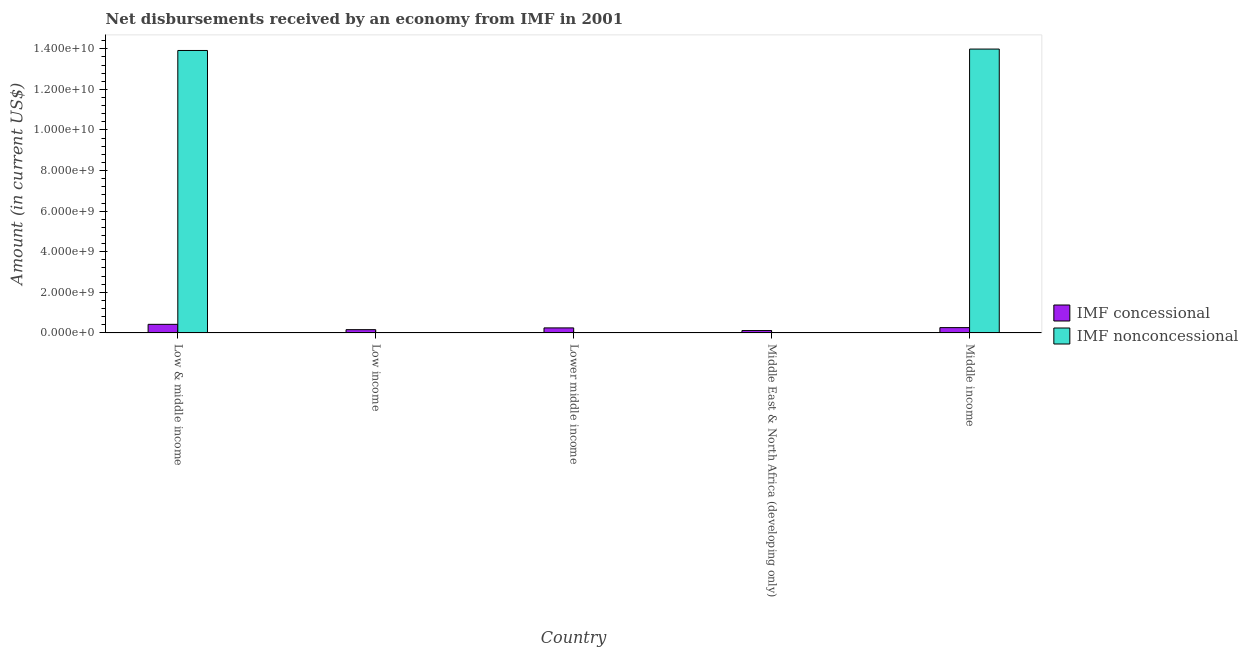How many different coloured bars are there?
Your response must be concise. 2. Are the number of bars per tick equal to the number of legend labels?
Your response must be concise. No. Are the number of bars on each tick of the X-axis equal?
Offer a very short reply. No. How many bars are there on the 1st tick from the right?
Provide a succinct answer. 2. What is the label of the 4th group of bars from the left?
Make the answer very short. Middle East & North Africa (developing only). What is the net non concessional disbursements from imf in Low income?
Keep it short and to the point. 0. Across all countries, what is the maximum net non concessional disbursements from imf?
Ensure brevity in your answer.  1.40e+1. Across all countries, what is the minimum net non concessional disbursements from imf?
Your answer should be compact. 0. What is the total net concessional disbursements from imf in the graph?
Provide a short and direct response. 1.21e+09. What is the difference between the net concessional disbursements from imf in Low & middle income and that in Lower middle income?
Your answer should be compact. 1.76e+08. What is the difference between the net non concessional disbursements from imf in Middle East & North Africa (developing only) and the net concessional disbursements from imf in Low & middle income?
Your response must be concise. -4.24e+08. What is the average net non concessional disbursements from imf per country?
Offer a very short reply. 5.58e+09. What is the difference between the net concessional disbursements from imf and net non concessional disbursements from imf in Low & middle income?
Keep it short and to the point. -1.35e+1. What is the ratio of the net non concessional disbursements from imf in Low & middle income to that in Middle income?
Ensure brevity in your answer.  1. Is the net non concessional disbursements from imf in Low & middle income less than that in Middle income?
Offer a terse response. Yes. What is the difference between the highest and the second highest net concessional disbursements from imf?
Your response must be concise. 1.62e+08. What is the difference between the highest and the lowest net concessional disbursements from imf?
Make the answer very short. 3.07e+08. Is the sum of the net concessional disbursements from imf in Lower middle income and Middle East & North Africa (developing only) greater than the maximum net non concessional disbursements from imf across all countries?
Your response must be concise. No. How many bars are there?
Provide a succinct answer. 7. What is the difference between two consecutive major ticks on the Y-axis?
Ensure brevity in your answer.  2.00e+09. Does the graph contain any zero values?
Offer a terse response. Yes. What is the title of the graph?
Offer a very short reply. Net disbursements received by an economy from IMF in 2001. Does "Resident workers" appear as one of the legend labels in the graph?
Give a very brief answer. No. What is the label or title of the X-axis?
Ensure brevity in your answer.  Country. What is the label or title of the Y-axis?
Provide a succinct answer. Amount (in current US$). What is the Amount (in current US$) of IMF concessional in Low & middle income?
Your answer should be compact. 4.24e+08. What is the Amount (in current US$) in IMF nonconcessional in Low & middle income?
Offer a terse response. 1.39e+1. What is the Amount (in current US$) of IMF concessional in Low income?
Your answer should be compact. 1.62e+08. What is the Amount (in current US$) in IMF concessional in Lower middle income?
Make the answer very short. 2.48e+08. What is the Amount (in current US$) of IMF nonconcessional in Lower middle income?
Offer a very short reply. 0. What is the Amount (in current US$) of IMF concessional in Middle East & North Africa (developing only)?
Your answer should be compact. 1.18e+08. What is the Amount (in current US$) in IMF nonconcessional in Middle East & North Africa (developing only)?
Your answer should be very brief. 0. What is the Amount (in current US$) of IMF concessional in Middle income?
Your response must be concise. 2.63e+08. What is the Amount (in current US$) in IMF nonconcessional in Middle income?
Offer a terse response. 1.40e+1. Across all countries, what is the maximum Amount (in current US$) of IMF concessional?
Ensure brevity in your answer.  4.24e+08. Across all countries, what is the maximum Amount (in current US$) of IMF nonconcessional?
Give a very brief answer. 1.40e+1. Across all countries, what is the minimum Amount (in current US$) in IMF concessional?
Offer a terse response. 1.18e+08. Across all countries, what is the minimum Amount (in current US$) in IMF nonconcessional?
Ensure brevity in your answer.  0. What is the total Amount (in current US$) in IMF concessional in the graph?
Provide a succinct answer. 1.21e+09. What is the total Amount (in current US$) in IMF nonconcessional in the graph?
Keep it short and to the point. 2.79e+1. What is the difference between the Amount (in current US$) of IMF concessional in Low & middle income and that in Low income?
Ensure brevity in your answer.  2.63e+08. What is the difference between the Amount (in current US$) of IMF concessional in Low & middle income and that in Lower middle income?
Provide a succinct answer. 1.76e+08. What is the difference between the Amount (in current US$) of IMF concessional in Low & middle income and that in Middle East & North Africa (developing only)?
Ensure brevity in your answer.  3.07e+08. What is the difference between the Amount (in current US$) of IMF concessional in Low & middle income and that in Middle income?
Give a very brief answer. 1.62e+08. What is the difference between the Amount (in current US$) in IMF nonconcessional in Low & middle income and that in Middle income?
Ensure brevity in your answer.  -6.98e+07. What is the difference between the Amount (in current US$) in IMF concessional in Low income and that in Lower middle income?
Offer a very short reply. -8.66e+07. What is the difference between the Amount (in current US$) of IMF concessional in Low income and that in Middle East & North Africa (developing only)?
Provide a succinct answer. 4.41e+07. What is the difference between the Amount (in current US$) in IMF concessional in Low income and that in Middle income?
Your answer should be very brief. -1.01e+08. What is the difference between the Amount (in current US$) in IMF concessional in Lower middle income and that in Middle East & North Africa (developing only)?
Give a very brief answer. 1.31e+08. What is the difference between the Amount (in current US$) of IMF concessional in Lower middle income and that in Middle income?
Your response must be concise. -1.43e+07. What is the difference between the Amount (in current US$) in IMF concessional in Middle East & North Africa (developing only) and that in Middle income?
Ensure brevity in your answer.  -1.45e+08. What is the difference between the Amount (in current US$) in IMF concessional in Low & middle income and the Amount (in current US$) in IMF nonconcessional in Middle income?
Provide a succinct answer. -1.36e+1. What is the difference between the Amount (in current US$) of IMF concessional in Low income and the Amount (in current US$) of IMF nonconcessional in Middle income?
Provide a short and direct response. -1.38e+1. What is the difference between the Amount (in current US$) of IMF concessional in Lower middle income and the Amount (in current US$) of IMF nonconcessional in Middle income?
Your answer should be very brief. -1.37e+1. What is the difference between the Amount (in current US$) in IMF concessional in Middle East & North Africa (developing only) and the Amount (in current US$) in IMF nonconcessional in Middle income?
Give a very brief answer. -1.39e+1. What is the average Amount (in current US$) in IMF concessional per country?
Make the answer very short. 2.43e+08. What is the average Amount (in current US$) in IMF nonconcessional per country?
Offer a very short reply. 5.58e+09. What is the difference between the Amount (in current US$) of IMF concessional and Amount (in current US$) of IMF nonconcessional in Low & middle income?
Keep it short and to the point. -1.35e+1. What is the difference between the Amount (in current US$) in IMF concessional and Amount (in current US$) in IMF nonconcessional in Middle income?
Your answer should be compact. -1.37e+1. What is the ratio of the Amount (in current US$) of IMF concessional in Low & middle income to that in Low income?
Your answer should be very brief. 2.62. What is the ratio of the Amount (in current US$) of IMF concessional in Low & middle income to that in Lower middle income?
Your response must be concise. 1.71. What is the ratio of the Amount (in current US$) of IMF concessional in Low & middle income to that in Middle East & North Africa (developing only)?
Give a very brief answer. 3.61. What is the ratio of the Amount (in current US$) of IMF concessional in Low & middle income to that in Middle income?
Offer a terse response. 1.62. What is the ratio of the Amount (in current US$) of IMF concessional in Low income to that in Lower middle income?
Your response must be concise. 0.65. What is the ratio of the Amount (in current US$) of IMF concessional in Low income to that in Middle East & North Africa (developing only)?
Your answer should be very brief. 1.37. What is the ratio of the Amount (in current US$) of IMF concessional in Low income to that in Middle income?
Offer a very short reply. 0.62. What is the ratio of the Amount (in current US$) of IMF concessional in Lower middle income to that in Middle East & North Africa (developing only)?
Ensure brevity in your answer.  2.11. What is the ratio of the Amount (in current US$) of IMF concessional in Lower middle income to that in Middle income?
Ensure brevity in your answer.  0.95. What is the ratio of the Amount (in current US$) of IMF concessional in Middle East & North Africa (developing only) to that in Middle income?
Provide a short and direct response. 0.45. What is the difference between the highest and the second highest Amount (in current US$) of IMF concessional?
Your response must be concise. 1.62e+08. What is the difference between the highest and the lowest Amount (in current US$) of IMF concessional?
Offer a terse response. 3.07e+08. What is the difference between the highest and the lowest Amount (in current US$) in IMF nonconcessional?
Keep it short and to the point. 1.40e+1. 